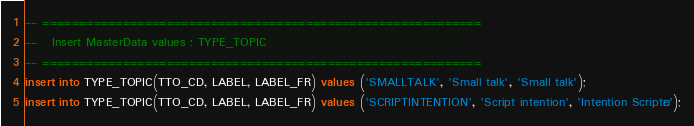Convert code to text. <code><loc_0><loc_0><loc_500><loc_500><_SQL_>-- ============================================================
--   Insert MasterData values : TYPE_TOPIC                                        
-- ============================================================
insert into TYPE_TOPIC(TTO_CD, LABEL, LABEL_FR) values ('SMALLTALK', 'Small talk', 'Small talk');
insert into TYPE_TOPIC(TTO_CD, LABEL, LABEL_FR) values ('SCRIPTINTENTION', 'Script intention', 'Intention Scriptée');
</code> 